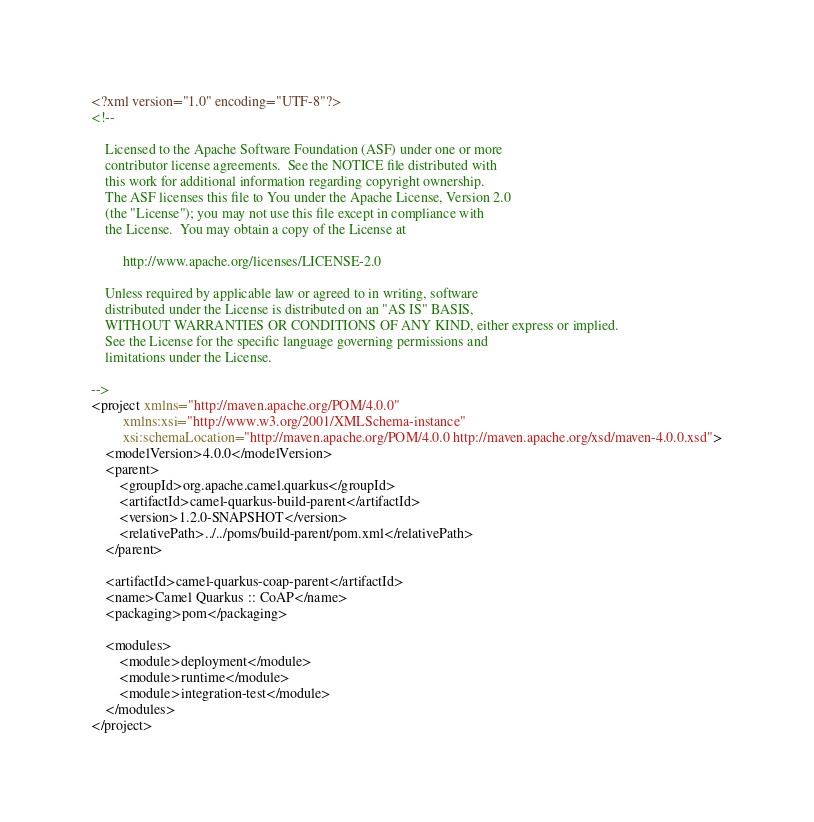Convert code to text. <code><loc_0><loc_0><loc_500><loc_500><_XML_><?xml version="1.0" encoding="UTF-8"?>
<!--

    Licensed to the Apache Software Foundation (ASF) under one or more
    contributor license agreements.  See the NOTICE file distributed with
    this work for additional information regarding copyright ownership.
    The ASF licenses this file to You under the Apache License, Version 2.0
    (the "License"); you may not use this file except in compliance with
    the License.  You may obtain a copy of the License at

         http://www.apache.org/licenses/LICENSE-2.0

    Unless required by applicable law or agreed to in writing, software
    distributed under the License is distributed on an "AS IS" BASIS,
    WITHOUT WARRANTIES OR CONDITIONS OF ANY KIND, either express or implied.
    See the License for the specific language governing permissions and
    limitations under the License.

-->
<project xmlns="http://maven.apache.org/POM/4.0.0"
         xmlns:xsi="http://www.w3.org/2001/XMLSchema-instance"
         xsi:schemaLocation="http://maven.apache.org/POM/4.0.0 http://maven.apache.org/xsd/maven-4.0.0.xsd">
    <modelVersion>4.0.0</modelVersion>
    <parent>
        <groupId>org.apache.camel.quarkus</groupId>
        <artifactId>camel-quarkus-build-parent</artifactId>
        <version>1.2.0-SNAPSHOT</version>
        <relativePath>../../poms/build-parent/pom.xml</relativePath>
    </parent>

    <artifactId>camel-quarkus-coap-parent</artifactId>
    <name>Camel Quarkus :: CoAP</name>
    <packaging>pom</packaging>

    <modules>
        <module>deployment</module>
        <module>runtime</module>
        <module>integration-test</module>
    </modules>
</project>
</code> 